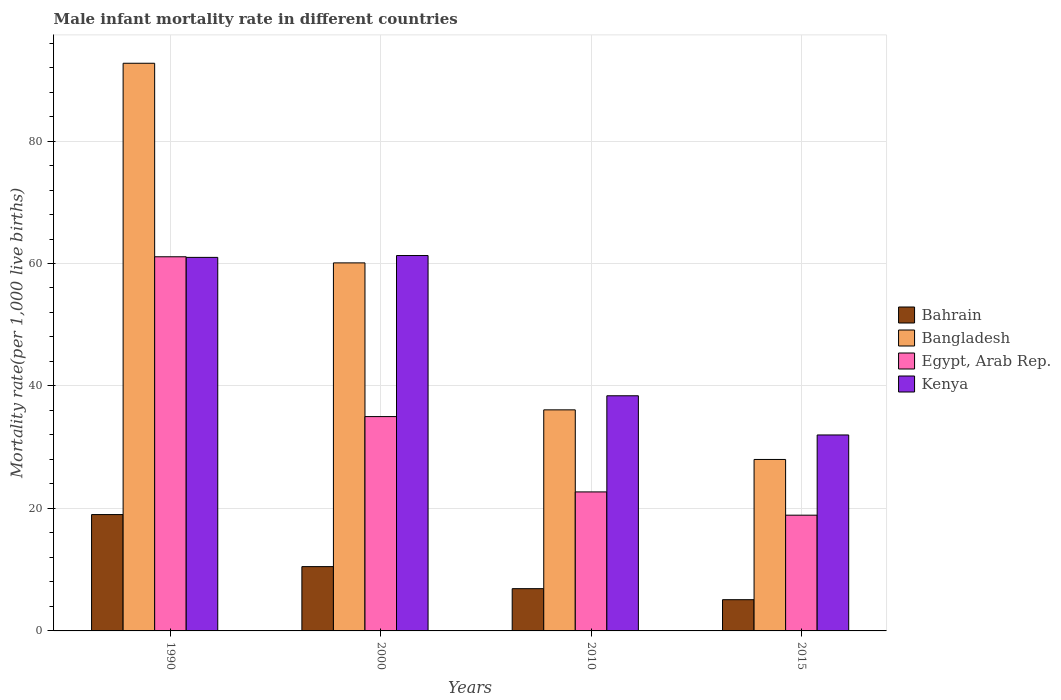How many different coloured bars are there?
Make the answer very short. 4. How many bars are there on the 2nd tick from the right?
Provide a short and direct response. 4. What is the label of the 4th group of bars from the left?
Provide a short and direct response. 2015. In how many cases, is the number of bars for a given year not equal to the number of legend labels?
Your answer should be very brief. 0. Across all years, what is the maximum male infant mortality rate in Kenya?
Ensure brevity in your answer.  61.3. Across all years, what is the minimum male infant mortality rate in Kenya?
Offer a very short reply. 32. In which year was the male infant mortality rate in Egypt, Arab Rep. minimum?
Provide a short and direct response. 2015. What is the total male infant mortality rate in Kenya in the graph?
Ensure brevity in your answer.  192.7. What is the difference between the male infant mortality rate in Kenya in 2010 and that in 2015?
Make the answer very short. 6.4. What is the difference between the male infant mortality rate in Kenya in 2015 and the male infant mortality rate in Bangladesh in 1990?
Provide a succinct answer. -60.7. What is the average male infant mortality rate in Bangladesh per year?
Ensure brevity in your answer.  54.23. In the year 2000, what is the difference between the male infant mortality rate in Kenya and male infant mortality rate in Egypt, Arab Rep.?
Your answer should be compact. 26.3. What is the ratio of the male infant mortality rate in Bangladesh in 1990 to that in 2000?
Your answer should be very brief. 1.54. Is the difference between the male infant mortality rate in Kenya in 2000 and 2015 greater than the difference between the male infant mortality rate in Egypt, Arab Rep. in 2000 and 2015?
Keep it short and to the point. Yes. What is the difference between the highest and the second highest male infant mortality rate in Bangladesh?
Ensure brevity in your answer.  32.6. What is the difference between the highest and the lowest male infant mortality rate in Bangladesh?
Offer a very short reply. 64.7. In how many years, is the male infant mortality rate in Bangladesh greater than the average male infant mortality rate in Bangladesh taken over all years?
Keep it short and to the point. 2. Is it the case that in every year, the sum of the male infant mortality rate in Bahrain and male infant mortality rate in Egypt, Arab Rep. is greater than the sum of male infant mortality rate in Bangladesh and male infant mortality rate in Kenya?
Give a very brief answer. No. What does the 1st bar from the left in 1990 represents?
Your answer should be compact. Bahrain. What does the 1st bar from the right in 2000 represents?
Provide a short and direct response. Kenya. How many bars are there?
Provide a succinct answer. 16. Are all the bars in the graph horizontal?
Give a very brief answer. No. Are the values on the major ticks of Y-axis written in scientific E-notation?
Ensure brevity in your answer.  No. Where does the legend appear in the graph?
Your response must be concise. Center right. What is the title of the graph?
Provide a short and direct response. Male infant mortality rate in different countries. What is the label or title of the X-axis?
Provide a short and direct response. Years. What is the label or title of the Y-axis?
Provide a succinct answer. Mortality rate(per 1,0 live births). What is the Mortality rate(per 1,000 live births) of Bangladesh in 1990?
Keep it short and to the point. 92.7. What is the Mortality rate(per 1,000 live births) of Egypt, Arab Rep. in 1990?
Offer a terse response. 61.1. What is the Mortality rate(per 1,000 live births) in Kenya in 1990?
Offer a very short reply. 61. What is the Mortality rate(per 1,000 live births) in Bahrain in 2000?
Offer a very short reply. 10.5. What is the Mortality rate(per 1,000 live births) of Bangladesh in 2000?
Your answer should be compact. 60.1. What is the Mortality rate(per 1,000 live births) of Kenya in 2000?
Provide a succinct answer. 61.3. What is the Mortality rate(per 1,000 live births) of Bangladesh in 2010?
Your answer should be very brief. 36.1. What is the Mortality rate(per 1,000 live births) of Egypt, Arab Rep. in 2010?
Your response must be concise. 22.7. What is the Mortality rate(per 1,000 live births) in Kenya in 2010?
Give a very brief answer. 38.4. Across all years, what is the maximum Mortality rate(per 1,000 live births) of Bahrain?
Provide a short and direct response. 19. Across all years, what is the maximum Mortality rate(per 1,000 live births) in Bangladesh?
Make the answer very short. 92.7. Across all years, what is the maximum Mortality rate(per 1,000 live births) of Egypt, Arab Rep.?
Provide a succinct answer. 61.1. Across all years, what is the maximum Mortality rate(per 1,000 live births) in Kenya?
Provide a short and direct response. 61.3. What is the total Mortality rate(per 1,000 live births) of Bahrain in the graph?
Give a very brief answer. 41.5. What is the total Mortality rate(per 1,000 live births) in Bangladesh in the graph?
Provide a succinct answer. 216.9. What is the total Mortality rate(per 1,000 live births) of Egypt, Arab Rep. in the graph?
Ensure brevity in your answer.  137.7. What is the total Mortality rate(per 1,000 live births) in Kenya in the graph?
Offer a very short reply. 192.7. What is the difference between the Mortality rate(per 1,000 live births) in Bahrain in 1990 and that in 2000?
Provide a short and direct response. 8.5. What is the difference between the Mortality rate(per 1,000 live births) in Bangladesh in 1990 and that in 2000?
Provide a short and direct response. 32.6. What is the difference between the Mortality rate(per 1,000 live births) in Egypt, Arab Rep. in 1990 and that in 2000?
Offer a terse response. 26.1. What is the difference between the Mortality rate(per 1,000 live births) of Bangladesh in 1990 and that in 2010?
Give a very brief answer. 56.6. What is the difference between the Mortality rate(per 1,000 live births) in Egypt, Arab Rep. in 1990 and that in 2010?
Make the answer very short. 38.4. What is the difference between the Mortality rate(per 1,000 live births) in Kenya in 1990 and that in 2010?
Provide a succinct answer. 22.6. What is the difference between the Mortality rate(per 1,000 live births) of Bangladesh in 1990 and that in 2015?
Offer a very short reply. 64.7. What is the difference between the Mortality rate(per 1,000 live births) of Egypt, Arab Rep. in 1990 and that in 2015?
Your answer should be very brief. 42.2. What is the difference between the Mortality rate(per 1,000 live births) in Bahrain in 2000 and that in 2010?
Ensure brevity in your answer.  3.6. What is the difference between the Mortality rate(per 1,000 live births) of Bangladesh in 2000 and that in 2010?
Give a very brief answer. 24. What is the difference between the Mortality rate(per 1,000 live births) in Kenya in 2000 and that in 2010?
Your answer should be very brief. 22.9. What is the difference between the Mortality rate(per 1,000 live births) of Bangladesh in 2000 and that in 2015?
Give a very brief answer. 32.1. What is the difference between the Mortality rate(per 1,000 live births) in Egypt, Arab Rep. in 2000 and that in 2015?
Keep it short and to the point. 16.1. What is the difference between the Mortality rate(per 1,000 live births) in Kenya in 2000 and that in 2015?
Give a very brief answer. 29.3. What is the difference between the Mortality rate(per 1,000 live births) of Bahrain in 2010 and that in 2015?
Provide a succinct answer. 1.8. What is the difference between the Mortality rate(per 1,000 live births) in Bahrain in 1990 and the Mortality rate(per 1,000 live births) in Bangladesh in 2000?
Offer a terse response. -41.1. What is the difference between the Mortality rate(per 1,000 live births) in Bahrain in 1990 and the Mortality rate(per 1,000 live births) in Egypt, Arab Rep. in 2000?
Make the answer very short. -16. What is the difference between the Mortality rate(per 1,000 live births) of Bahrain in 1990 and the Mortality rate(per 1,000 live births) of Kenya in 2000?
Ensure brevity in your answer.  -42.3. What is the difference between the Mortality rate(per 1,000 live births) of Bangladesh in 1990 and the Mortality rate(per 1,000 live births) of Egypt, Arab Rep. in 2000?
Make the answer very short. 57.7. What is the difference between the Mortality rate(per 1,000 live births) of Bangladesh in 1990 and the Mortality rate(per 1,000 live births) of Kenya in 2000?
Provide a short and direct response. 31.4. What is the difference between the Mortality rate(per 1,000 live births) of Egypt, Arab Rep. in 1990 and the Mortality rate(per 1,000 live births) of Kenya in 2000?
Offer a terse response. -0.2. What is the difference between the Mortality rate(per 1,000 live births) in Bahrain in 1990 and the Mortality rate(per 1,000 live births) in Bangladesh in 2010?
Give a very brief answer. -17.1. What is the difference between the Mortality rate(per 1,000 live births) in Bahrain in 1990 and the Mortality rate(per 1,000 live births) in Egypt, Arab Rep. in 2010?
Your answer should be compact. -3.7. What is the difference between the Mortality rate(per 1,000 live births) in Bahrain in 1990 and the Mortality rate(per 1,000 live births) in Kenya in 2010?
Provide a succinct answer. -19.4. What is the difference between the Mortality rate(per 1,000 live births) in Bangladesh in 1990 and the Mortality rate(per 1,000 live births) in Egypt, Arab Rep. in 2010?
Provide a succinct answer. 70. What is the difference between the Mortality rate(per 1,000 live births) in Bangladesh in 1990 and the Mortality rate(per 1,000 live births) in Kenya in 2010?
Your answer should be very brief. 54.3. What is the difference between the Mortality rate(per 1,000 live births) of Egypt, Arab Rep. in 1990 and the Mortality rate(per 1,000 live births) of Kenya in 2010?
Offer a very short reply. 22.7. What is the difference between the Mortality rate(per 1,000 live births) in Bahrain in 1990 and the Mortality rate(per 1,000 live births) in Bangladesh in 2015?
Provide a succinct answer. -9. What is the difference between the Mortality rate(per 1,000 live births) in Bangladesh in 1990 and the Mortality rate(per 1,000 live births) in Egypt, Arab Rep. in 2015?
Offer a terse response. 73.8. What is the difference between the Mortality rate(per 1,000 live births) in Bangladesh in 1990 and the Mortality rate(per 1,000 live births) in Kenya in 2015?
Your answer should be very brief. 60.7. What is the difference between the Mortality rate(per 1,000 live births) of Egypt, Arab Rep. in 1990 and the Mortality rate(per 1,000 live births) of Kenya in 2015?
Provide a succinct answer. 29.1. What is the difference between the Mortality rate(per 1,000 live births) of Bahrain in 2000 and the Mortality rate(per 1,000 live births) of Bangladesh in 2010?
Give a very brief answer. -25.6. What is the difference between the Mortality rate(per 1,000 live births) in Bahrain in 2000 and the Mortality rate(per 1,000 live births) in Egypt, Arab Rep. in 2010?
Keep it short and to the point. -12.2. What is the difference between the Mortality rate(per 1,000 live births) in Bahrain in 2000 and the Mortality rate(per 1,000 live births) in Kenya in 2010?
Your answer should be very brief. -27.9. What is the difference between the Mortality rate(per 1,000 live births) in Bangladesh in 2000 and the Mortality rate(per 1,000 live births) in Egypt, Arab Rep. in 2010?
Keep it short and to the point. 37.4. What is the difference between the Mortality rate(per 1,000 live births) in Bangladesh in 2000 and the Mortality rate(per 1,000 live births) in Kenya in 2010?
Provide a short and direct response. 21.7. What is the difference between the Mortality rate(per 1,000 live births) of Egypt, Arab Rep. in 2000 and the Mortality rate(per 1,000 live births) of Kenya in 2010?
Make the answer very short. -3.4. What is the difference between the Mortality rate(per 1,000 live births) in Bahrain in 2000 and the Mortality rate(per 1,000 live births) in Bangladesh in 2015?
Provide a succinct answer. -17.5. What is the difference between the Mortality rate(per 1,000 live births) of Bahrain in 2000 and the Mortality rate(per 1,000 live births) of Kenya in 2015?
Provide a short and direct response. -21.5. What is the difference between the Mortality rate(per 1,000 live births) in Bangladesh in 2000 and the Mortality rate(per 1,000 live births) in Egypt, Arab Rep. in 2015?
Provide a short and direct response. 41.2. What is the difference between the Mortality rate(per 1,000 live births) of Bangladesh in 2000 and the Mortality rate(per 1,000 live births) of Kenya in 2015?
Provide a succinct answer. 28.1. What is the difference between the Mortality rate(per 1,000 live births) of Bahrain in 2010 and the Mortality rate(per 1,000 live births) of Bangladesh in 2015?
Offer a very short reply. -21.1. What is the difference between the Mortality rate(per 1,000 live births) in Bahrain in 2010 and the Mortality rate(per 1,000 live births) in Egypt, Arab Rep. in 2015?
Your response must be concise. -12. What is the difference between the Mortality rate(per 1,000 live births) of Bahrain in 2010 and the Mortality rate(per 1,000 live births) of Kenya in 2015?
Provide a short and direct response. -25.1. What is the difference between the Mortality rate(per 1,000 live births) in Egypt, Arab Rep. in 2010 and the Mortality rate(per 1,000 live births) in Kenya in 2015?
Ensure brevity in your answer.  -9.3. What is the average Mortality rate(per 1,000 live births) of Bahrain per year?
Provide a short and direct response. 10.38. What is the average Mortality rate(per 1,000 live births) of Bangladesh per year?
Provide a short and direct response. 54.23. What is the average Mortality rate(per 1,000 live births) of Egypt, Arab Rep. per year?
Your answer should be very brief. 34.42. What is the average Mortality rate(per 1,000 live births) in Kenya per year?
Offer a very short reply. 48.17. In the year 1990, what is the difference between the Mortality rate(per 1,000 live births) of Bahrain and Mortality rate(per 1,000 live births) of Bangladesh?
Your answer should be compact. -73.7. In the year 1990, what is the difference between the Mortality rate(per 1,000 live births) of Bahrain and Mortality rate(per 1,000 live births) of Egypt, Arab Rep.?
Your answer should be compact. -42.1. In the year 1990, what is the difference between the Mortality rate(per 1,000 live births) in Bahrain and Mortality rate(per 1,000 live births) in Kenya?
Offer a terse response. -42. In the year 1990, what is the difference between the Mortality rate(per 1,000 live births) in Bangladesh and Mortality rate(per 1,000 live births) in Egypt, Arab Rep.?
Your response must be concise. 31.6. In the year 1990, what is the difference between the Mortality rate(per 1,000 live births) of Bangladesh and Mortality rate(per 1,000 live births) of Kenya?
Ensure brevity in your answer.  31.7. In the year 1990, what is the difference between the Mortality rate(per 1,000 live births) in Egypt, Arab Rep. and Mortality rate(per 1,000 live births) in Kenya?
Keep it short and to the point. 0.1. In the year 2000, what is the difference between the Mortality rate(per 1,000 live births) in Bahrain and Mortality rate(per 1,000 live births) in Bangladesh?
Offer a very short reply. -49.6. In the year 2000, what is the difference between the Mortality rate(per 1,000 live births) in Bahrain and Mortality rate(per 1,000 live births) in Egypt, Arab Rep.?
Provide a short and direct response. -24.5. In the year 2000, what is the difference between the Mortality rate(per 1,000 live births) in Bahrain and Mortality rate(per 1,000 live births) in Kenya?
Provide a short and direct response. -50.8. In the year 2000, what is the difference between the Mortality rate(per 1,000 live births) in Bangladesh and Mortality rate(per 1,000 live births) in Egypt, Arab Rep.?
Keep it short and to the point. 25.1. In the year 2000, what is the difference between the Mortality rate(per 1,000 live births) in Egypt, Arab Rep. and Mortality rate(per 1,000 live births) in Kenya?
Give a very brief answer. -26.3. In the year 2010, what is the difference between the Mortality rate(per 1,000 live births) of Bahrain and Mortality rate(per 1,000 live births) of Bangladesh?
Provide a succinct answer. -29.2. In the year 2010, what is the difference between the Mortality rate(per 1,000 live births) of Bahrain and Mortality rate(per 1,000 live births) of Egypt, Arab Rep.?
Your answer should be compact. -15.8. In the year 2010, what is the difference between the Mortality rate(per 1,000 live births) of Bahrain and Mortality rate(per 1,000 live births) of Kenya?
Make the answer very short. -31.5. In the year 2010, what is the difference between the Mortality rate(per 1,000 live births) in Egypt, Arab Rep. and Mortality rate(per 1,000 live births) in Kenya?
Your response must be concise. -15.7. In the year 2015, what is the difference between the Mortality rate(per 1,000 live births) in Bahrain and Mortality rate(per 1,000 live births) in Bangladesh?
Provide a short and direct response. -22.9. In the year 2015, what is the difference between the Mortality rate(per 1,000 live births) in Bahrain and Mortality rate(per 1,000 live births) in Kenya?
Provide a short and direct response. -26.9. In the year 2015, what is the difference between the Mortality rate(per 1,000 live births) of Egypt, Arab Rep. and Mortality rate(per 1,000 live births) of Kenya?
Offer a very short reply. -13.1. What is the ratio of the Mortality rate(per 1,000 live births) in Bahrain in 1990 to that in 2000?
Your answer should be compact. 1.81. What is the ratio of the Mortality rate(per 1,000 live births) in Bangladesh in 1990 to that in 2000?
Offer a very short reply. 1.54. What is the ratio of the Mortality rate(per 1,000 live births) in Egypt, Arab Rep. in 1990 to that in 2000?
Provide a short and direct response. 1.75. What is the ratio of the Mortality rate(per 1,000 live births) in Kenya in 1990 to that in 2000?
Provide a short and direct response. 1. What is the ratio of the Mortality rate(per 1,000 live births) of Bahrain in 1990 to that in 2010?
Your answer should be compact. 2.75. What is the ratio of the Mortality rate(per 1,000 live births) in Bangladesh in 1990 to that in 2010?
Your answer should be very brief. 2.57. What is the ratio of the Mortality rate(per 1,000 live births) of Egypt, Arab Rep. in 1990 to that in 2010?
Offer a terse response. 2.69. What is the ratio of the Mortality rate(per 1,000 live births) in Kenya in 1990 to that in 2010?
Provide a succinct answer. 1.59. What is the ratio of the Mortality rate(per 1,000 live births) of Bahrain in 1990 to that in 2015?
Ensure brevity in your answer.  3.73. What is the ratio of the Mortality rate(per 1,000 live births) in Bangladesh in 1990 to that in 2015?
Provide a short and direct response. 3.31. What is the ratio of the Mortality rate(per 1,000 live births) of Egypt, Arab Rep. in 1990 to that in 2015?
Make the answer very short. 3.23. What is the ratio of the Mortality rate(per 1,000 live births) in Kenya in 1990 to that in 2015?
Make the answer very short. 1.91. What is the ratio of the Mortality rate(per 1,000 live births) in Bahrain in 2000 to that in 2010?
Ensure brevity in your answer.  1.52. What is the ratio of the Mortality rate(per 1,000 live births) of Bangladesh in 2000 to that in 2010?
Your answer should be compact. 1.66. What is the ratio of the Mortality rate(per 1,000 live births) of Egypt, Arab Rep. in 2000 to that in 2010?
Make the answer very short. 1.54. What is the ratio of the Mortality rate(per 1,000 live births) of Kenya in 2000 to that in 2010?
Give a very brief answer. 1.6. What is the ratio of the Mortality rate(per 1,000 live births) in Bahrain in 2000 to that in 2015?
Keep it short and to the point. 2.06. What is the ratio of the Mortality rate(per 1,000 live births) in Bangladesh in 2000 to that in 2015?
Your response must be concise. 2.15. What is the ratio of the Mortality rate(per 1,000 live births) in Egypt, Arab Rep. in 2000 to that in 2015?
Provide a short and direct response. 1.85. What is the ratio of the Mortality rate(per 1,000 live births) in Kenya in 2000 to that in 2015?
Provide a short and direct response. 1.92. What is the ratio of the Mortality rate(per 1,000 live births) of Bahrain in 2010 to that in 2015?
Give a very brief answer. 1.35. What is the ratio of the Mortality rate(per 1,000 live births) of Bangladesh in 2010 to that in 2015?
Make the answer very short. 1.29. What is the ratio of the Mortality rate(per 1,000 live births) of Egypt, Arab Rep. in 2010 to that in 2015?
Ensure brevity in your answer.  1.2. What is the difference between the highest and the second highest Mortality rate(per 1,000 live births) of Bahrain?
Make the answer very short. 8.5. What is the difference between the highest and the second highest Mortality rate(per 1,000 live births) in Bangladesh?
Make the answer very short. 32.6. What is the difference between the highest and the second highest Mortality rate(per 1,000 live births) in Egypt, Arab Rep.?
Your answer should be compact. 26.1. What is the difference between the highest and the lowest Mortality rate(per 1,000 live births) in Bahrain?
Offer a very short reply. 13.9. What is the difference between the highest and the lowest Mortality rate(per 1,000 live births) of Bangladesh?
Provide a succinct answer. 64.7. What is the difference between the highest and the lowest Mortality rate(per 1,000 live births) in Egypt, Arab Rep.?
Make the answer very short. 42.2. What is the difference between the highest and the lowest Mortality rate(per 1,000 live births) of Kenya?
Make the answer very short. 29.3. 